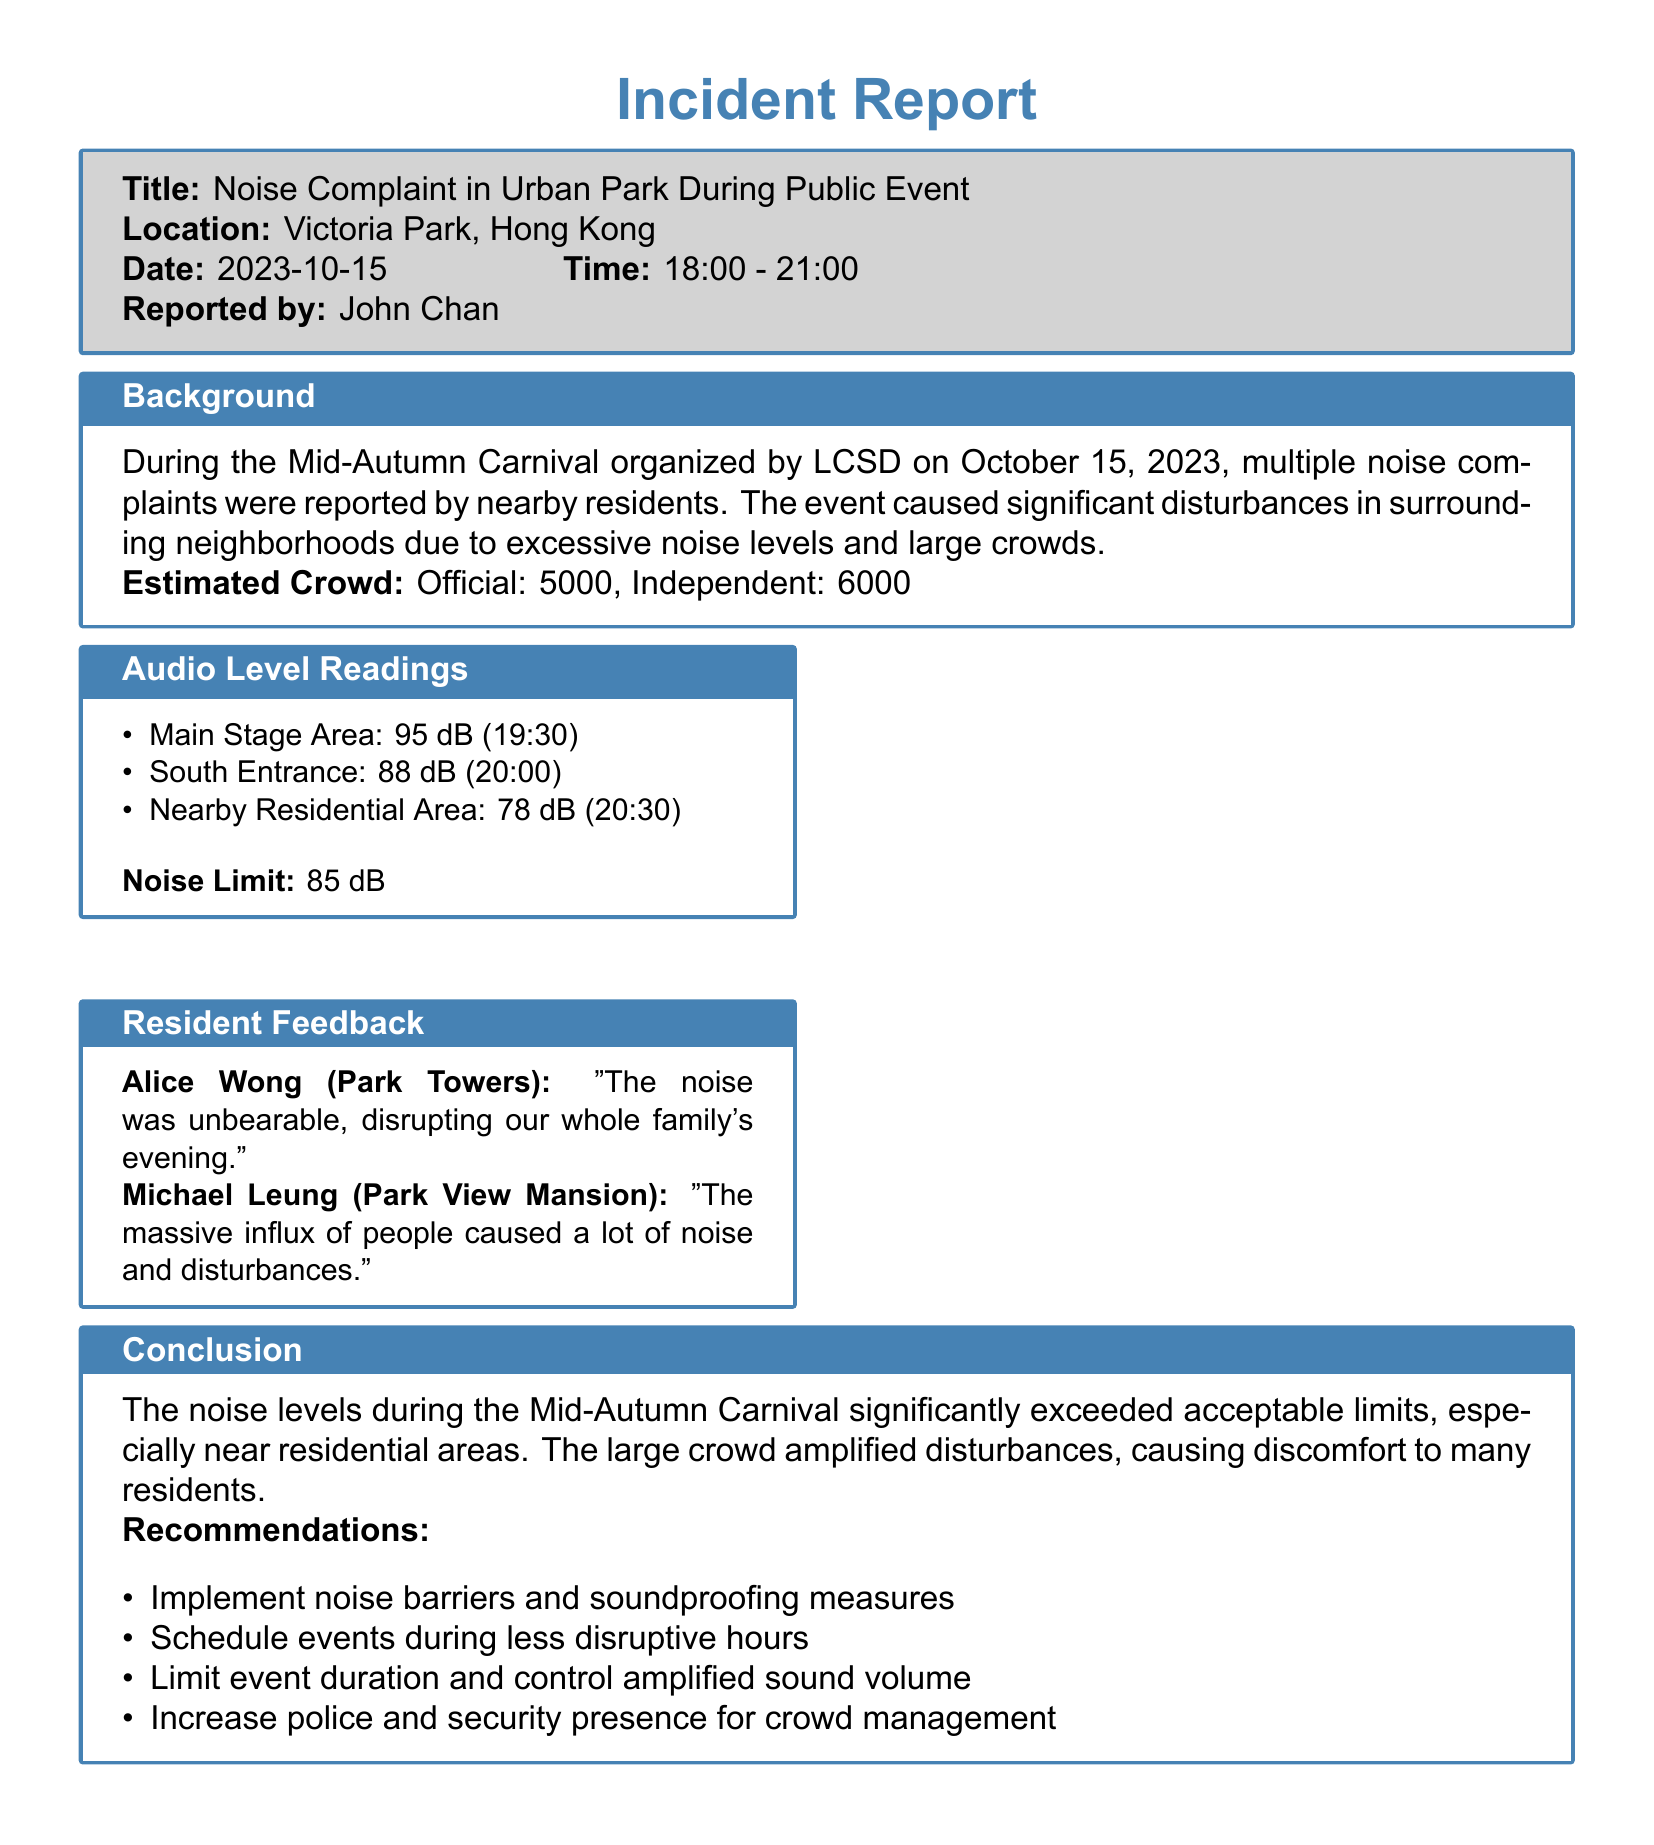What was the date of the Mid-Autumn Carnival? The date of the Mid-Autumn Carnival is stated directly in the document, which is October 15, 2023.
Answer: October 15, 2023 What was the estimated crowd according to the official report? The documented estimated crowd according to the official report is listed under the "Estimated Crowd" section.
Answer: 5000 What was the audio level reading at the Main Stage Area? The audio level reading for the Main Stage Area at 19:30 is provided in the "Audio Level Readings" section.
Answer: 95 dB What is the noise limit defined in the report? The noise limit is specified in the "Audio Level Readings" section of the document.
Answer: 85 dB Which resident reported that "the noise was unbearable"? The individual who made this statement is noted in the "Resident Feedback" section of the report.
Answer: Alice Wong What time was the audio level reading taken at the South Entrance? The time associated with the audio level reading at the South Entrance is clearly indicated in the report.
Answer: 20:00 What are two recommendations mentioned in the conclusion? The recommendations are listed under the "Conclusion" section and can be directly quoted from there.
Answer: Noise barriers and soundproofing measures What was the audio level reading in the Nearby Residential Area? The audio level reading for the Nearby Residential Area at 20:30 is indicated in the document.
Answer: 78 dB What is the name of the person who reported the incident? The name of the person who reported the incident is located at the top of the document.
Answer: John Chan 